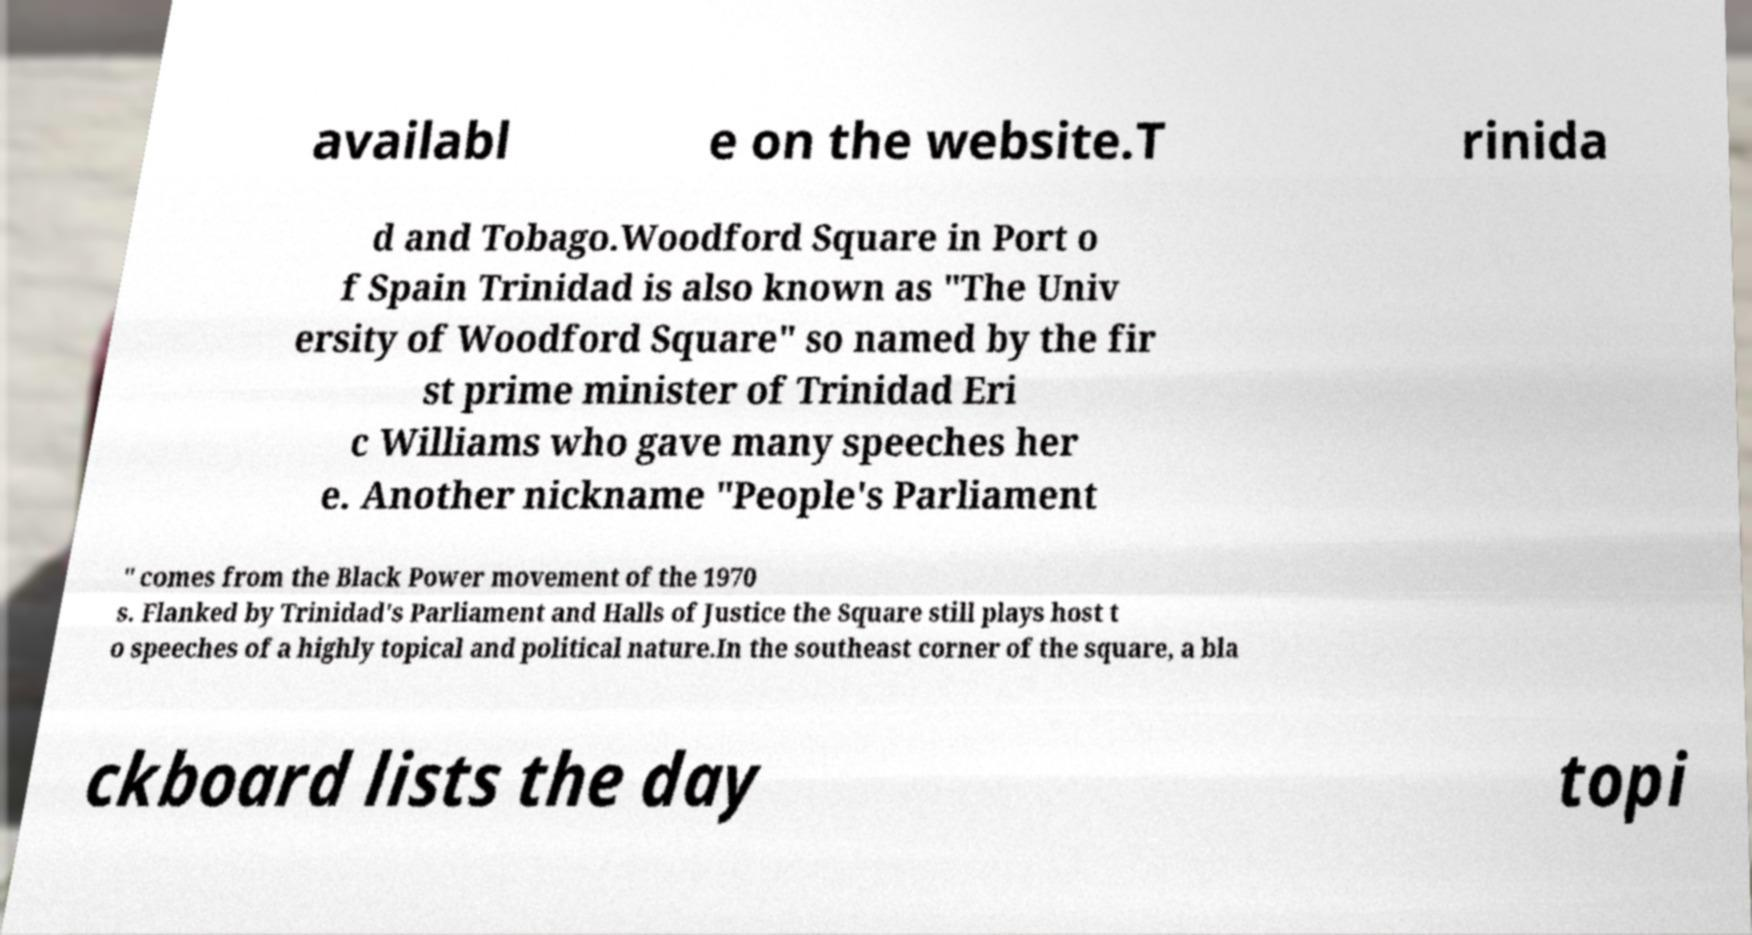Please read and relay the text visible in this image. What does it say? availabl e on the website.T rinida d and Tobago.Woodford Square in Port o f Spain Trinidad is also known as "The Univ ersity of Woodford Square" so named by the fir st prime minister of Trinidad Eri c Williams who gave many speeches her e. Another nickname "People's Parliament " comes from the Black Power movement of the 1970 s. Flanked by Trinidad's Parliament and Halls of Justice the Square still plays host t o speeches of a highly topical and political nature.In the southeast corner of the square, a bla ckboard lists the day topi 